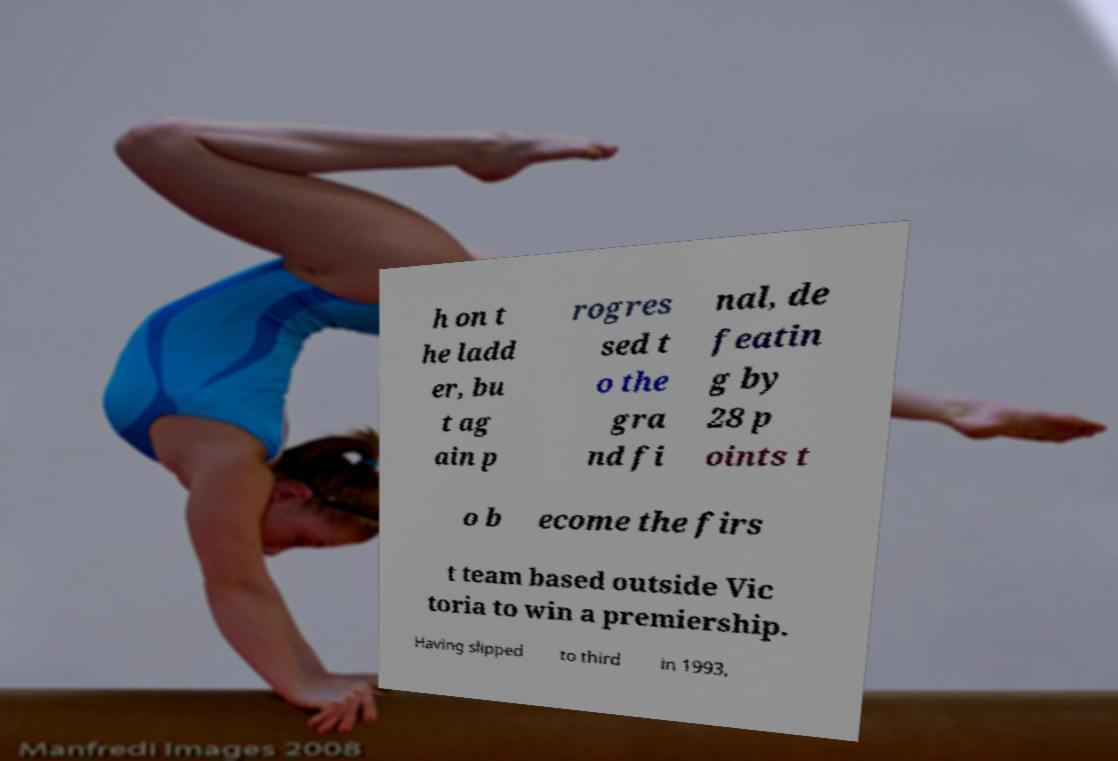For documentation purposes, I need the text within this image transcribed. Could you provide that? h on t he ladd er, bu t ag ain p rogres sed t o the gra nd fi nal, de featin g by 28 p oints t o b ecome the firs t team based outside Vic toria to win a premiership. Having slipped to third in 1993, 